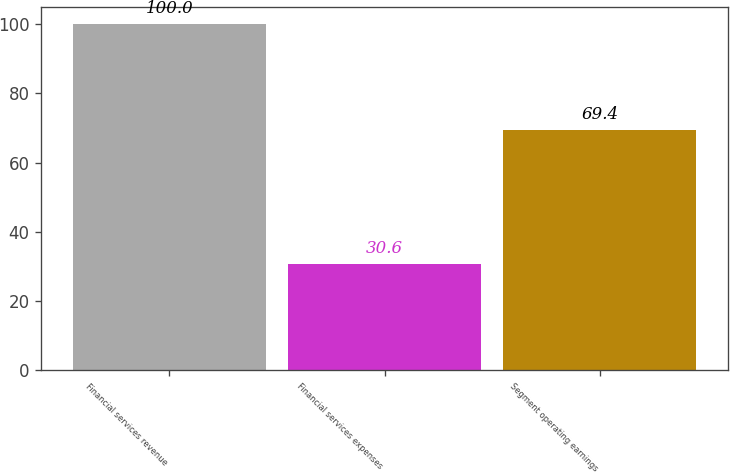Convert chart. <chart><loc_0><loc_0><loc_500><loc_500><bar_chart><fcel>Financial services revenue<fcel>Financial services expenses<fcel>Segment operating earnings<nl><fcel>100<fcel>30.6<fcel>69.4<nl></chart> 